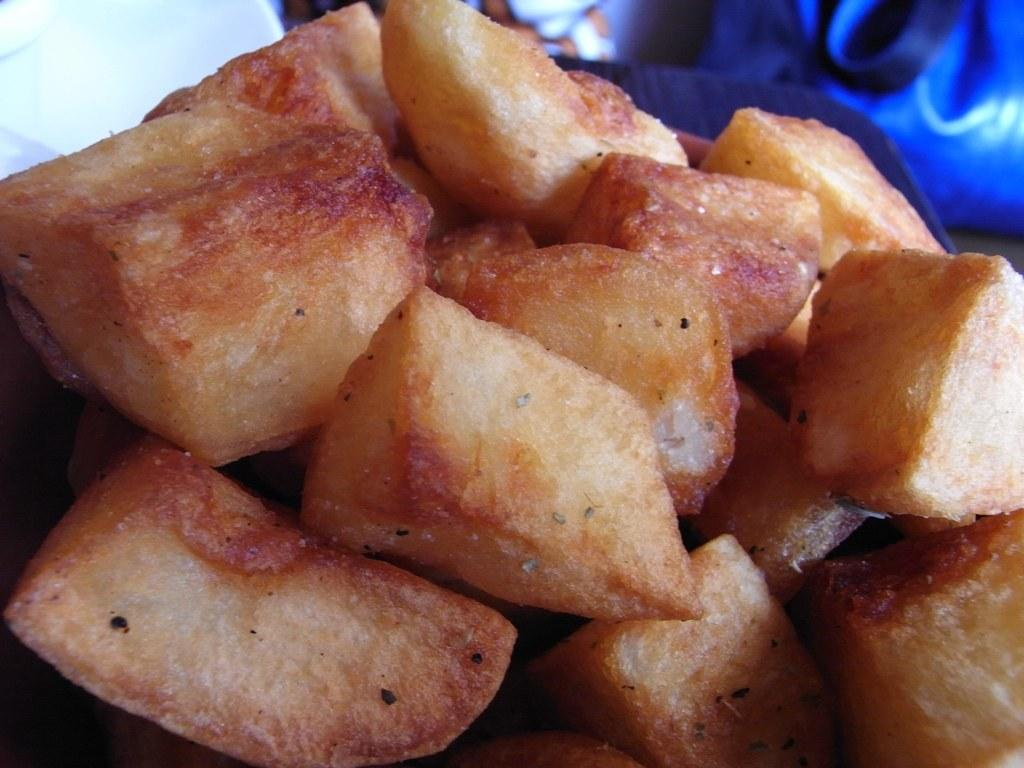What is the main subject of the image? The main subject of the image is food items in the center. Can you describe the food items in the image? Unfortunately, the provided facts do not specify the type of food items in the image. What else can be seen in the image besides the food items? There are other objects visible in the background of the image. How many buttons are on the flower in the image? There is no flower or button present in the image. 